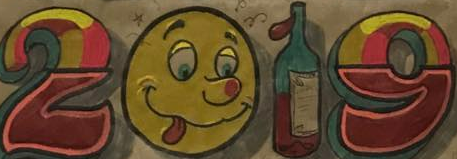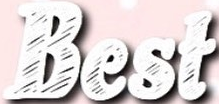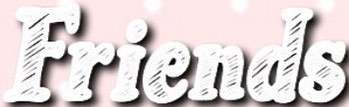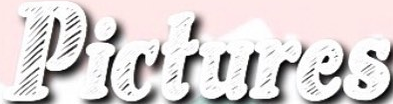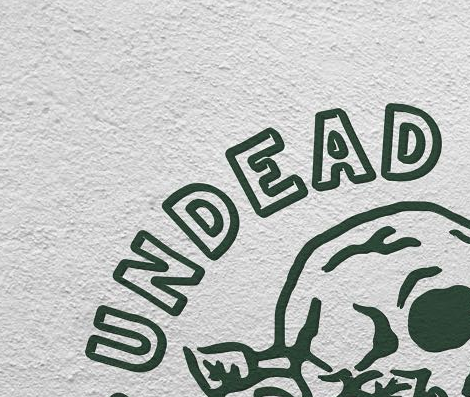Read the text content from these images in order, separated by a semicolon. 2019; Best; Friends; Pictures; UNDEAD 